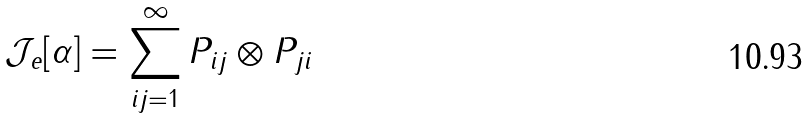<formula> <loc_0><loc_0><loc_500><loc_500>\mathcal { J } _ { e } [ \alpha ] = \sum _ { i j = 1 } ^ { \infty } P _ { i j } \otimes P _ { j i }</formula> 